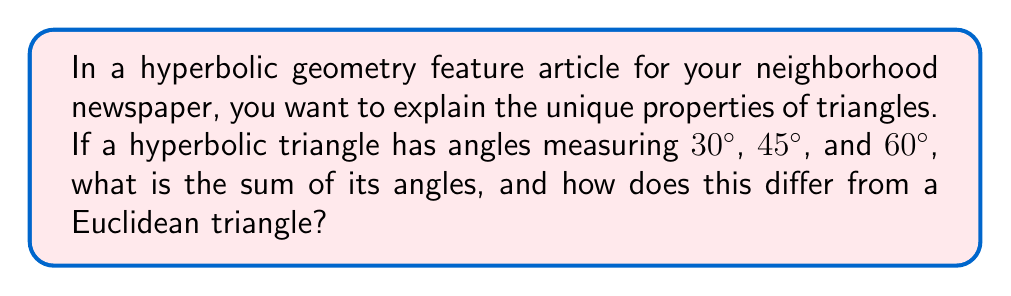What is the answer to this math problem? Let's approach this step-by-step:

1) In Euclidean geometry, the sum of angles in a triangle is always 180°. However, in hyperbolic geometry, this is not the case.

2) In hyperbolic geometry, the sum of angles in a triangle is always less than 180°. This is a fundamental property of hyperbolic triangles.

3) To find the sum of angles in this specific hyperbolic triangle:
   $$30° + 45° + 60° = 135°$$

4) The difference between this sum and 180° is called the defect of the triangle:
   $$\text{Defect} = 180° - (30° + 45° + 60°) = 180° - 135° = 45°$$

5) In hyperbolic geometry, the area of a triangle is directly proportional to its defect. The larger the defect, the larger the area of the triangle.

6) To contrast with Euclidean geometry:
   - Euclidean triangle: Sum of angles = 180°
   - This hyperbolic triangle: Sum of angles = 135°

7) The difference of 45° represents the curvature of the hyperbolic plane, which causes the sum of angles to be less than 180°.
Answer: 135°; 45° less than a Euclidean triangle 